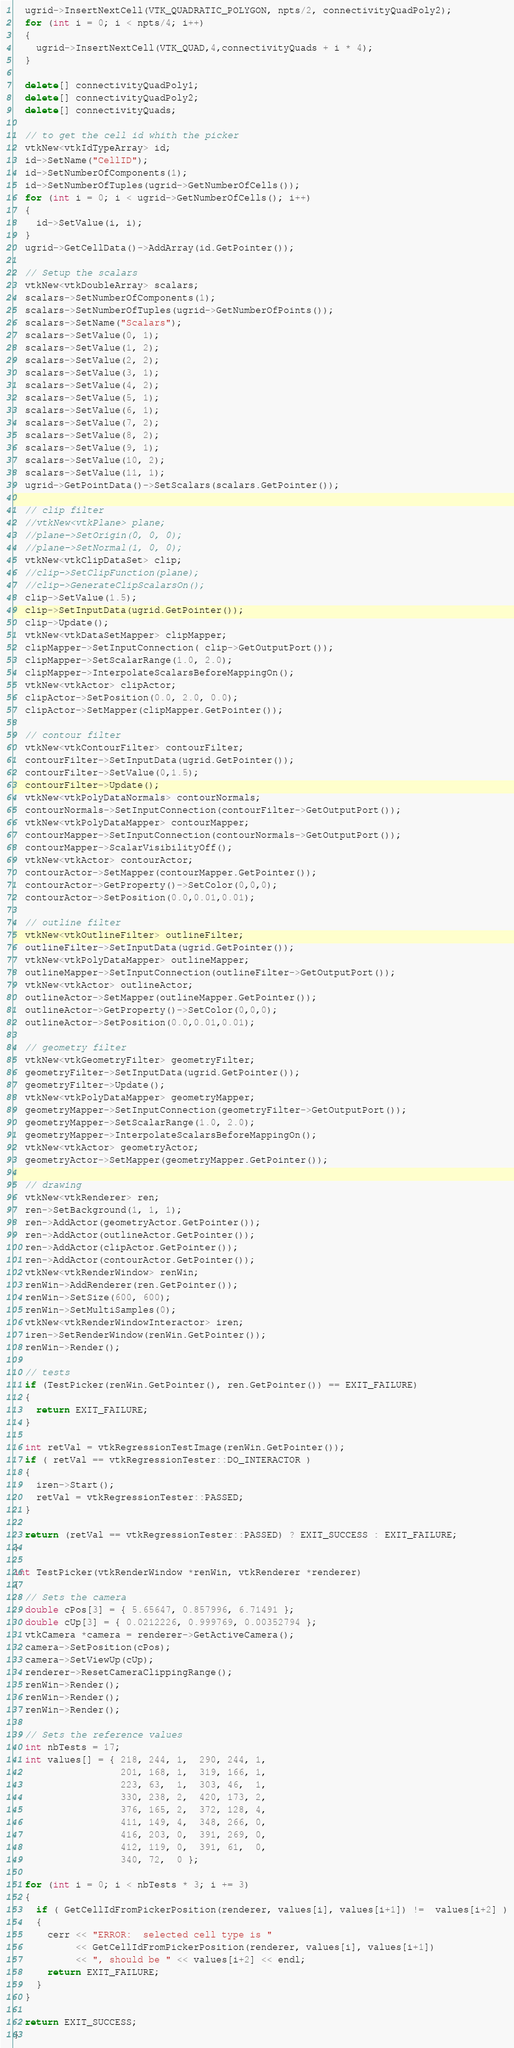Convert code to text. <code><loc_0><loc_0><loc_500><loc_500><_C++_>  ugrid->InsertNextCell(VTK_QUADRATIC_POLYGON, npts/2, connectivityQuadPoly2);
  for (int i = 0; i < npts/4; i++)
  {
    ugrid->InsertNextCell(VTK_QUAD,4,connectivityQuads + i * 4);
  }

  delete[] connectivityQuadPoly1;
  delete[] connectivityQuadPoly2;
  delete[] connectivityQuads;

  // to get the cell id whith the picker
  vtkNew<vtkIdTypeArray> id;
  id->SetName("CellID");
  id->SetNumberOfComponents(1);
  id->SetNumberOfTuples(ugrid->GetNumberOfCells());
  for (int i = 0; i < ugrid->GetNumberOfCells(); i++)
  {
    id->SetValue(i, i);
  }
  ugrid->GetCellData()->AddArray(id.GetPointer());

  // Setup the scalars
  vtkNew<vtkDoubleArray> scalars;
  scalars->SetNumberOfComponents(1);
  scalars->SetNumberOfTuples(ugrid->GetNumberOfPoints());
  scalars->SetName("Scalars");
  scalars->SetValue(0, 1);
  scalars->SetValue(1, 2);
  scalars->SetValue(2, 2);
  scalars->SetValue(3, 1);
  scalars->SetValue(4, 2);
  scalars->SetValue(5, 1);
  scalars->SetValue(6, 1);
  scalars->SetValue(7, 2);
  scalars->SetValue(8, 2);
  scalars->SetValue(9, 1);
  scalars->SetValue(10, 2);
  scalars->SetValue(11, 1);
  ugrid->GetPointData()->SetScalars(scalars.GetPointer());

  // clip filter
  //vtkNew<vtkPlane> plane;
  //plane->SetOrigin(0, 0, 0);
  //plane->SetNormal(1, 0, 0);
  vtkNew<vtkClipDataSet> clip;
  //clip->SetClipFunction(plane);
  //clip->GenerateClipScalarsOn();
  clip->SetValue(1.5);
  clip->SetInputData(ugrid.GetPointer());
  clip->Update();
  vtkNew<vtkDataSetMapper> clipMapper;
  clipMapper->SetInputConnection( clip->GetOutputPort());
  clipMapper->SetScalarRange(1.0, 2.0);
  clipMapper->InterpolateScalarsBeforeMappingOn();
  vtkNew<vtkActor> clipActor;
  clipActor->SetPosition(0.0, 2.0, 0.0);
  clipActor->SetMapper(clipMapper.GetPointer());

  // contour filter
  vtkNew<vtkContourFilter> contourFilter;
  contourFilter->SetInputData(ugrid.GetPointer());
  contourFilter->SetValue(0,1.5);
  contourFilter->Update();
  vtkNew<vtkPolyDataNormals> contourNormals;
  contourNormals->SetInputConnection(contourFilter->GetOutputPort());
  vtkNew<vtkPolyDataMapper> contourMapper;
  contourMapper->SetInputConnection(contourNormals->GetOutputPort());
  contourMapper->ScalarVisibilityOff();
  vtkNew<vtkActor> contourActor;
  contourActor->SetMapper(contourMapper.GetPointer());
  contourActor->GetProperty()->SetColor(0,0,0);
  contourActor->SetPosition(0.0,0.01,0.01);

  // outline filter
  vtkNew<vtkOutlineFilter> outlineFilter;
  outlineFilter->SetInputData(ugrid.GetPointer());
  vtkNew<vtkPolyDataMapper> outlineMapper;
  outlineMapper->SetInputConnection(outlineFilter->GetOutputPort());
  vtkNew<vtkActor> outlineActor;
  outlineActor->SetMapper(outlineMapper.GetPointer());
  outlineActor->GetProperty()->SetColor(0,0,0);
  outlineActor->SetPosition(0.0,0.01,0.01);

  // geometry filter
  vtkNew<vtkGeometryFilter> geometryFilter;
  geometryFilter->SetInputData(ugrid.GetPointer());
  geometryFilter->Update();
  vtkNew<vtkPolyDataMapper> geometryMapper;
  geometryMapper->SetInputConnection(geometryFilter->GetOutputPort());
  geometryMapper->SetScalarRange(1.0, 2.0);
  geometryMapper->InterpolateScalarsBeforeMappingOn();
  vtkNew<vtkActor> geometryActor;
  geometryActor->SetMapper(geometryMapper.GetPointer());

  // drawing
  vtkNew<vtkRenderer> ren;
  ren->SetBackground(1, 1, 1);
  ren->AddActor(geometryActor.GetPointer());
  ren->AddActor(outlineActor.GetPointer());
  ren->AddActor(clipActor.GetPointer());
  ren->AddActor(contourActor.GetPointer());
  vtkNew<vtkRenderWindow> renWin;
  renWin->AddRenderer(ren.GetPointer());
  renWin->SetSize(600, 600);
  renWin->SetMultiSamples(0);
  vtkNew<vtkRenderWindowInteractor> iren;
  iren->SetRenderWindow(renWin.GetPointer());
  renWin->Render();

  // tests
  if (TestPicker(renWin.GetPointer(), ren.GetPointer()) == EXIT_FAILURE)
  {
    return EXIT_FAILURE;
  }

  int retVal = vtkRegressionTestImage(renWin.GetPointer());
  if ( retVal == vtkRegressionTester::DO_INTERACTOR )
  {
    iren->Start();
    retVal = vtkRegressionTester::PASSED;
  }

  return (retVal == vtkRegressionTester::PASSED) ? EXIT_SUCCESS : EXIT_FAILURE;
}

int TestPicker(vtkRenderWindow *renWin, vtkRenderer *renderer)
{
  // Sets the camera
  double cPos[3] = { 5.65647, 0.857996, 6.71491 };
  double cUp[3] = { 0.0212226, 0.999769, 0.00352794 };
  vtkCamera *camera = renderer->GetActiveCamera();
  camera->SetPosition(cPos);
  camera->SetViewUp(cUp);
  renderer->ResetCameraClippingRange();
  renWin->Render();
  renWin->Render();
  renWin->Render();

  // Sets the reference values
  int nbTests = 17;
  int values[] = { 218, 244, 1,  290, 244, 1,
                   201, 168, 1,  319, 166, 1,
                   223, 63,  1,  303, 46,  1,
                   330, 238, 2,  420, 173, 2,
                   376, 165, 2,  372, 128, 4,
                   411, 149, 4,  348, 266, 0,
                   416, 203, 0,  391, 269, 0,
                   412, 119, 0,  391, 61,  0,
                   340, 72,  0 };

  for (int i = 0; i < nbTests * 3; i += 3)
  {
    if ( GetCellIdFromPickerPosition(renderer, values[i], values[i+1]) !=  values[i+2] )
    {
      cerr << "ERROR:  selected cell type is "
           << GetCellIdFromPickerPosition(renderer, values[i], values[i+1])
           << ", should be " << values[i+2] << endl;
      return EXIT_FAILURE;
    }
  }

  return EXIT_SUCCESS;
}
</code> 